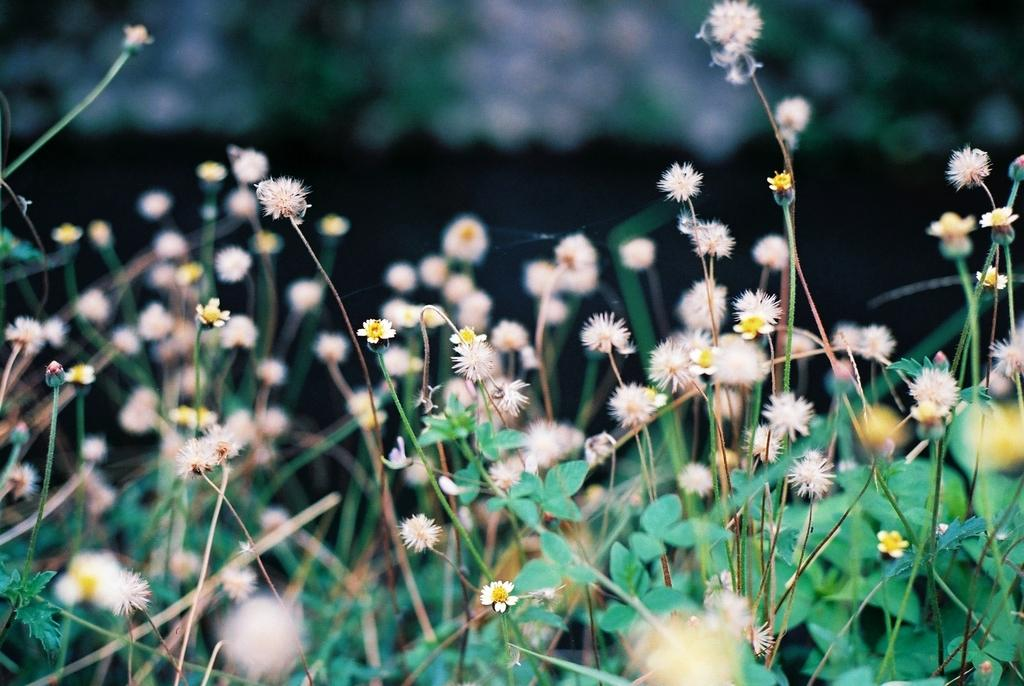What type of plants can be seen in the image? There are flower plants in the image. What type of fowl can be seen interacting with the flower plants in the image? There is no fowl present in the image; it only features flower plants. What type of metal is used to create the lock on the flower plants in the image? There is no lock present in the image; it only features flower plants. 